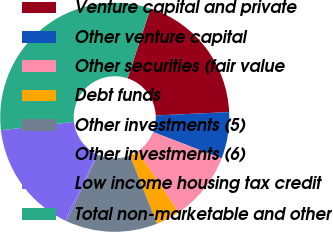Convert chart. <chart><loc_0><loc_0><loc_500><loc_500><pie_chart><fcel>Venture capital and private<fcel>Other venture capital<fcel>Other securities (fair value<fcel>Debt funds<fcel>Other investments (5)<fcel>Other investments (6)<fcel>Low income housing tax credit<fcel>Total non-marketable and other<nl><fcel>19.22%<fcel>6.57%<fcel>9.73%<fcel>3.41%<fcel>12.9%<fcel>0.25%<fcel>16.06%<fcel>31.87%<nl></chart> 